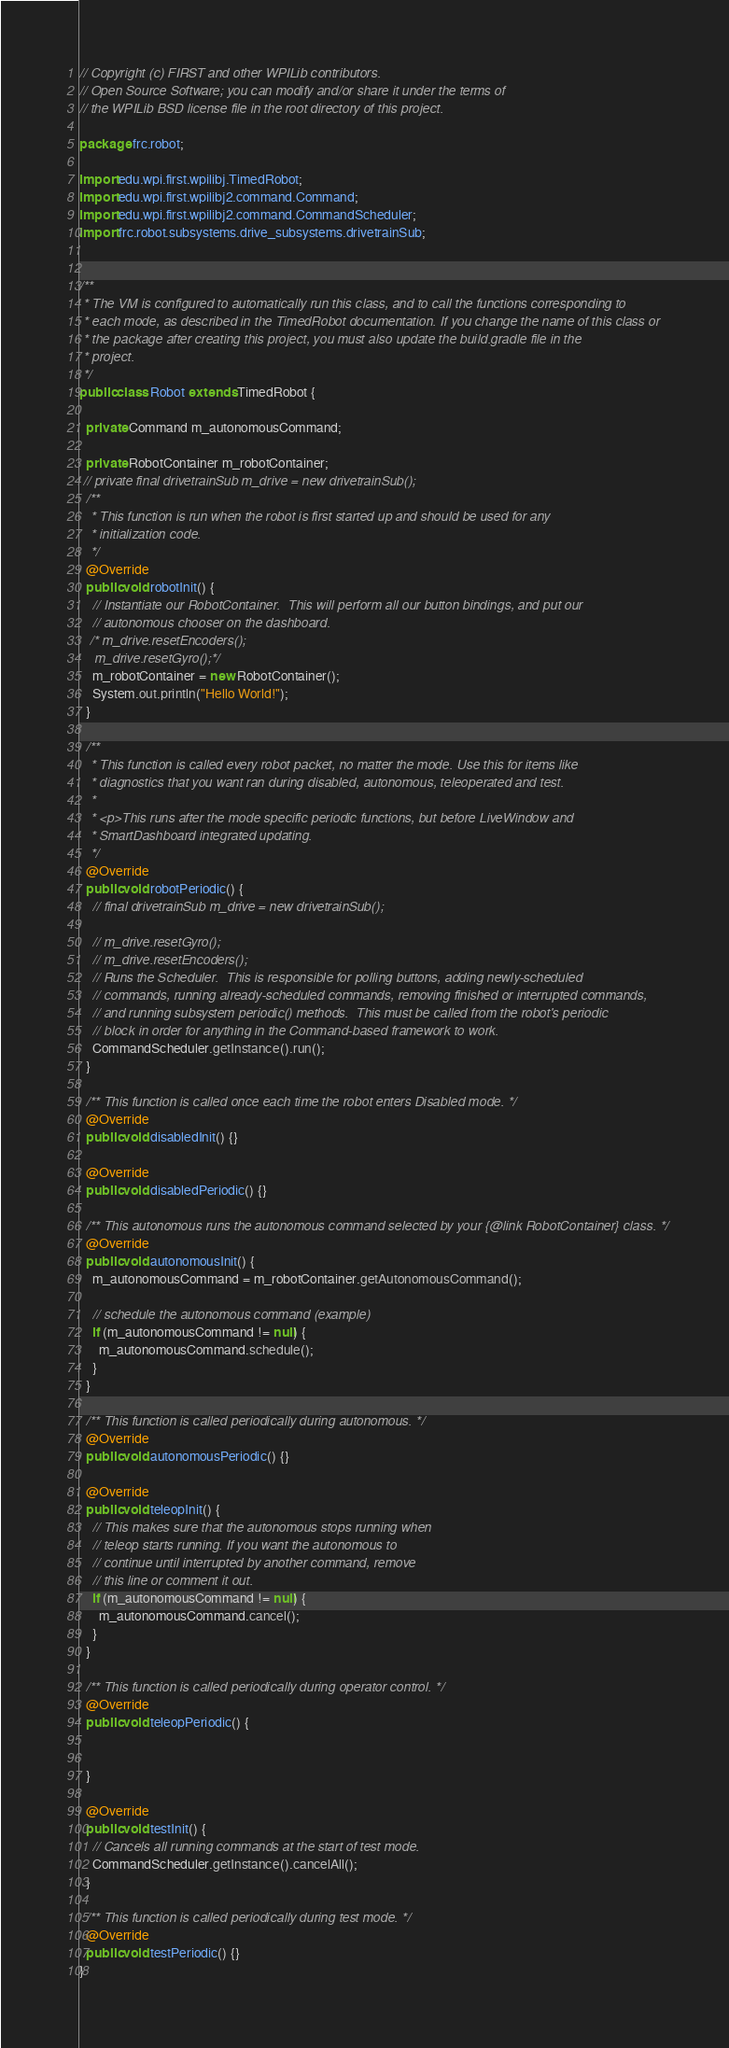Convert code to text. <code><loc_0><loc_0><loc_500><loc_500><_Java_>// Copyright (c) FIRST and other WPILib contributors.
// Open Source Software; you can modify and/or share it under the terms of
// the WPILib BSD license file in the root directory of this project.

package frc.robot;

import edu.wpi.first.wpilibj.TimedRobot;
import edu.wpi.first.wpilibj2.command.Command;
import edu.wpi.first.wpilibj2.command.CommandScheduler;
import frc.robot.subsystems.drive_subsystems.drivetrainSub;


/**
 * The VM is configured to automatically run this class, and to call the functions corresponding to
 * each mode, as described in the TimedRobot documentation. If you change the name of this class or
 * the package after creating this project, you must also update the build.gradle file in the
 * project.
 */
public class Robot extends TimedRobot {
  
  private Command m_autonomousCommand;

  private RobotContainer m_robotContainer;
 // private final drivetrainSub m_drive = new drivetrainSub();
  /**
   * This function is run when the robot is first started up and should be used for any
   * initialization code.
   */
  @Override
  public void robotInit() {
    // Instantiate our RobotContainer.  This will perform all our button bindings, and put our
    // autonomous chooser on the dashboard.
   /* m_drive.resetEncoders();
    m_drive.resetGyro();*/
    m_robotContainer = new RobotContainer();
    System.out.println("Hello World!");
  }

  /**
   * This function is called every robot packet, no matter the mode. Use this for items like
   * diagnostics that you want ran during disabled, autonomous, teleoperated and test.
   *
   * <p>This runs after the mode specific periodic functions, but before LiveWindow and
   * SmartDashboard integrated updating.
   */
  @Override
  public void robotPeriodic() {
    // final drivetrainSub m_drive = new drivetrainSub();

    // m_drive.resetGyro();
    // m_drive.resetEncoders();
    // Runs the Scheduler.  This is responsible for polling buttons, adding newly-scheduled
    // commands, running already-scheduled commands, removing finished or interrupted commands,
    // and running subsystem periodic() methods.  This must be called from the robot's periodic
    // block in order for anything in the Command-based framework to work.
    CommandScheduler.getInstance().run();
  }

  /** This function is called once each time the robot enters Disabled mode. */
  @Override
  public void disabledInit() {}

  @Override
  public void disabledPeriodic() {}

  /** This autonomous runs the autonomous command selected by your {@link RobotContainer} class. */
  @Override
  public void autonomousInit() {
    m_autonomousCommand = m_robotContainer.getAutonomousCommand();

    // schedule the autonomous command (example)
    if (m_autonomousCommand != null) {
      m_autonomousCommand.schedule();
    }
  }

  /** This function is called periodically during autonomous. */
  @Override
  public void autonomousPeriodic() {}

  @Override
  public void teleopInit() {
    // This makes sure that the autonomous stops running when
    // teleop starts running. If you want the autonomous to
    // continue until interrupted by another command, remove
    // this line or comment it out.
    if (m_autonomousCommand != null) {
      m_autonomousCommand.cancel();
    }
  }

  /** This function is called periodically during operator control. */
  @Override
  public void teleopPeriodic() {
    

  }

  @Override
  public void testInit() {
    // Cancels all running commands at the start of test mode.
    CommandScheduler.getInstance().cancelAll();
  }

  /** This function is called periodically during test mode. */
  @Override
  public void testPeriodic() {}
}
</code> 